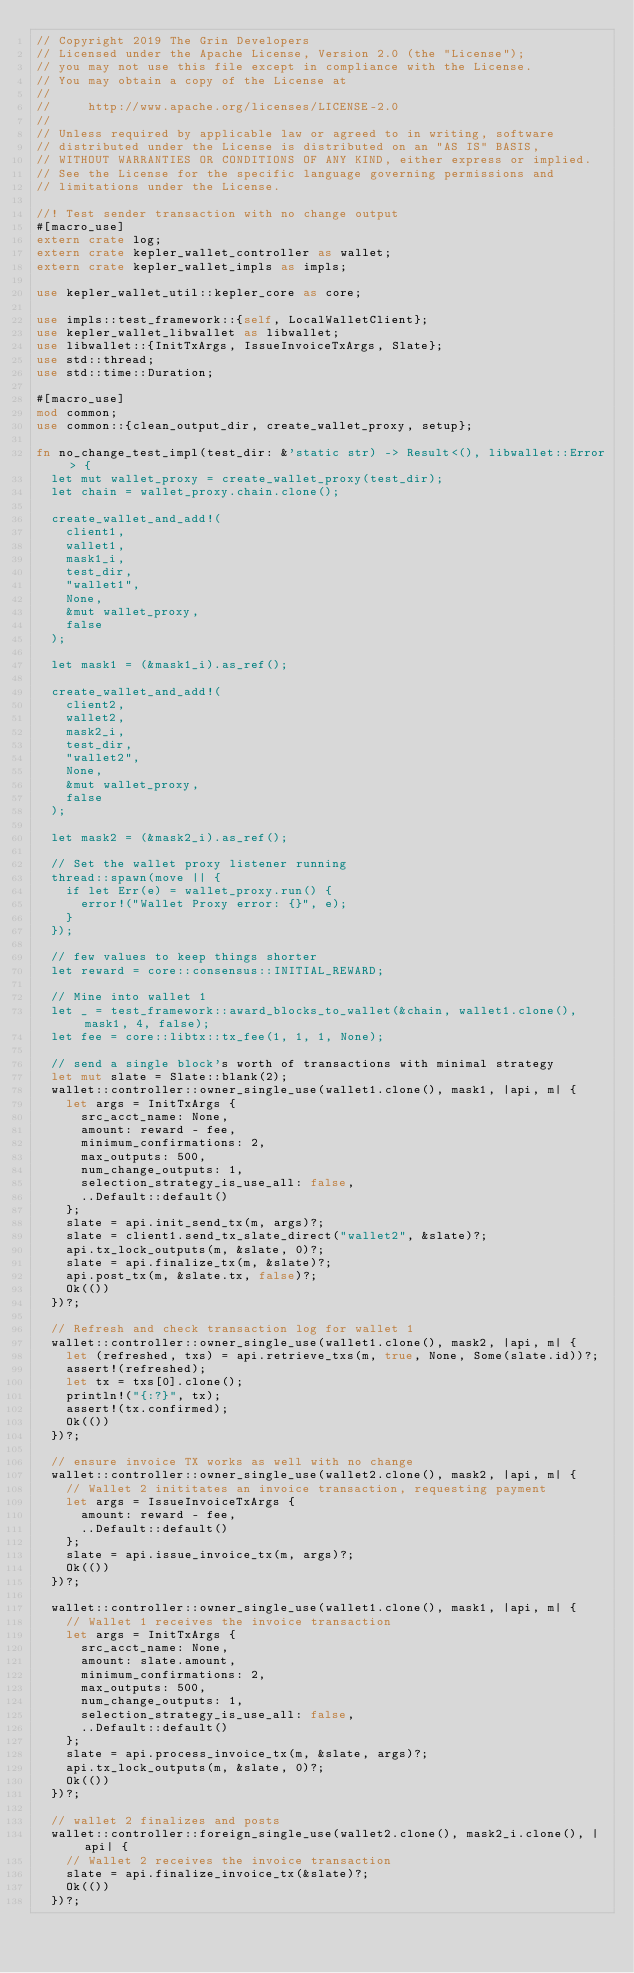Convert code to text. <code><loc_0><loc_0><loc_500><loc_500><_Rust_>// Copyright 2019 The Grin Developers
// Licensed under the Apache License, Version 2.0 (the "License");
// you may not use this file except in compliance with the License.
// You may obtain a copy of the License at
//
//     http://www.apache.org/licenses/LICENSE-2.0
//
// Unless required by applicable law or agreed to in writing, software
// distributed under the License is distributed on an "AS IS" BASIS,
// WITHOUT WARRANTIES OR CONDITIONS OF ANY KIND, either express or implied.
// See the License for the specific language governing permissions and
// limitations under the License.

//! Test sender transaction with no change output
#[macro_use]
extern crate log;
extern crate kepler_wallet_controller as wallet;
extern crate kepler_wallet_impls as impls;

use kepler_wallet_util::kepler_core as core;

use impls::test_framework::{self, LocalWalletClient};
use kepler_wallet_libwallet as libwallet;
use libwallet::{InitTxArgs, IssueInvoiceTxArgs, Slate};
use std::thread;
use std::time::Duration;

#[macro_use]
mod common;
use common::{clean_output_dir, create_wallet_proxy, setup};

fn no_change_test_impl(test_dir: &'static str) -> Result<(), libwallet::Error> {
	let mut wallet_proxy = create_wallet_proxy(test_dir);
	let chain = wallet_proxy.chain.clone();

	create_wallet_and_add!(
		client1,
		wallet1,
		mask1_i,
		test_dir,
		"wallet1",
		None,
		&mut wallet_proxy,
		false
	);

	let mask1 = (&mask1_i).as_ref();

	create_wallet_and_add!(
		client2,
		wallet2,
		mask2_i,
		test_dir,
		"wallet2",
		None,
		&mut wallet_proxy,
		false
	);

	let mask2 = (&mask2_i).as_ref();

	// Set the wallet proxy listener running
	thread::spawn(move || {
		if let Err(e) = wallet_proxy.run() {
			error!("Wallet Proxy error: {}", e);
		}
	});

	// few values to keep things shorter
	let reward = core::consensus::INITIAL_REWARD;

	// Mine into wallet 1
	let _ = test_framework::award_blocks_to_wallet(&chain, wallet1.clone(), mask1, 4, false);
	let fee = core::libtx::tx_fee(1, 1, 1, None);

	// send a single block's worth of transactions with minimal strategy
	let mut slate = Slate::blank(2);
	wallet::controller::owner_single_use(wallet1.clone(), mask1, |api, m| {
		let args = InitTxArgs {
			src_acct_name: None,
			amount: reward - fee,
			minimum_confirmations: 2,
			max_outputs: 500,
			num_change_outputs: 1,
			selection_strategy_is_use_all: false,
			..Default::default()
		};
		slate = api.init_send_tx(m, args)?;
		slate = client1.send_tx_slate_direct("wallet2", &slate)?;
		api.tx_lock_outputs(m, &slate, 0)?;
		slate = api.finalize_tx(m, &slate)?;
		api.post_tx(m, &slate.tx, false)?;
		Ok(())
	})?;

	// Refresh and check transaction log for wallet 1
	wallet::controller::owner_single_use(wallet1.clone(), mask2, |api, m| {
		let (refreshed, txs) = api.retrieve_txs(m, true, None, Some(slate.id))?;
		assert!(refreshed);
		let tx = txs[0].clone();
		println!("{:?}", tx);
		assert!(tx.confirmed);
		Ok(())
	})?;

	// ensure invoice TX works as well with no change
	wallet::controller::owner_single_use(wallet2.clone(), mask2, |api, m| {
		// Wallet 2 inititates an invoice transaction, requesting payment
		let args = IssueInvoiceTxArgs {
			amount: reward - fee,
			..Default::default()
		};
		slate = api.issue_invoice_tx(m, args)?;
		Ok(())
	})?;

	wallet::controller::owner_single_use(wallet1.clone(), mask1, |api, m| {
		// Wallet 1 receives the invoice transaction
		let args = InitTxArgs {
			src_acct_name: None,
			amount: slate.amount,
			minimum_confirmations: 2,
			max_outputs: 500,
			num_change_outputs: 1,
			selection_strategy_is_use_all: false,
			..Default::default()
		};
		slate = api.process_invoice_tx(m, &slate, args)?;
		api.tx_lock_outputs(m, &slate, 0)?;
		Ok(())
	})?;

	// wallet 2 finalizes and posts
	wallet::controller::foreign_single_use(wallet2.clone(), mask2_i.clone(), |api| {
		// Wallet 2 receives the invoice transaction
		slate = api.finalize_invoice_tx(&slate)?;
		Ok(())
	})?;</code> 